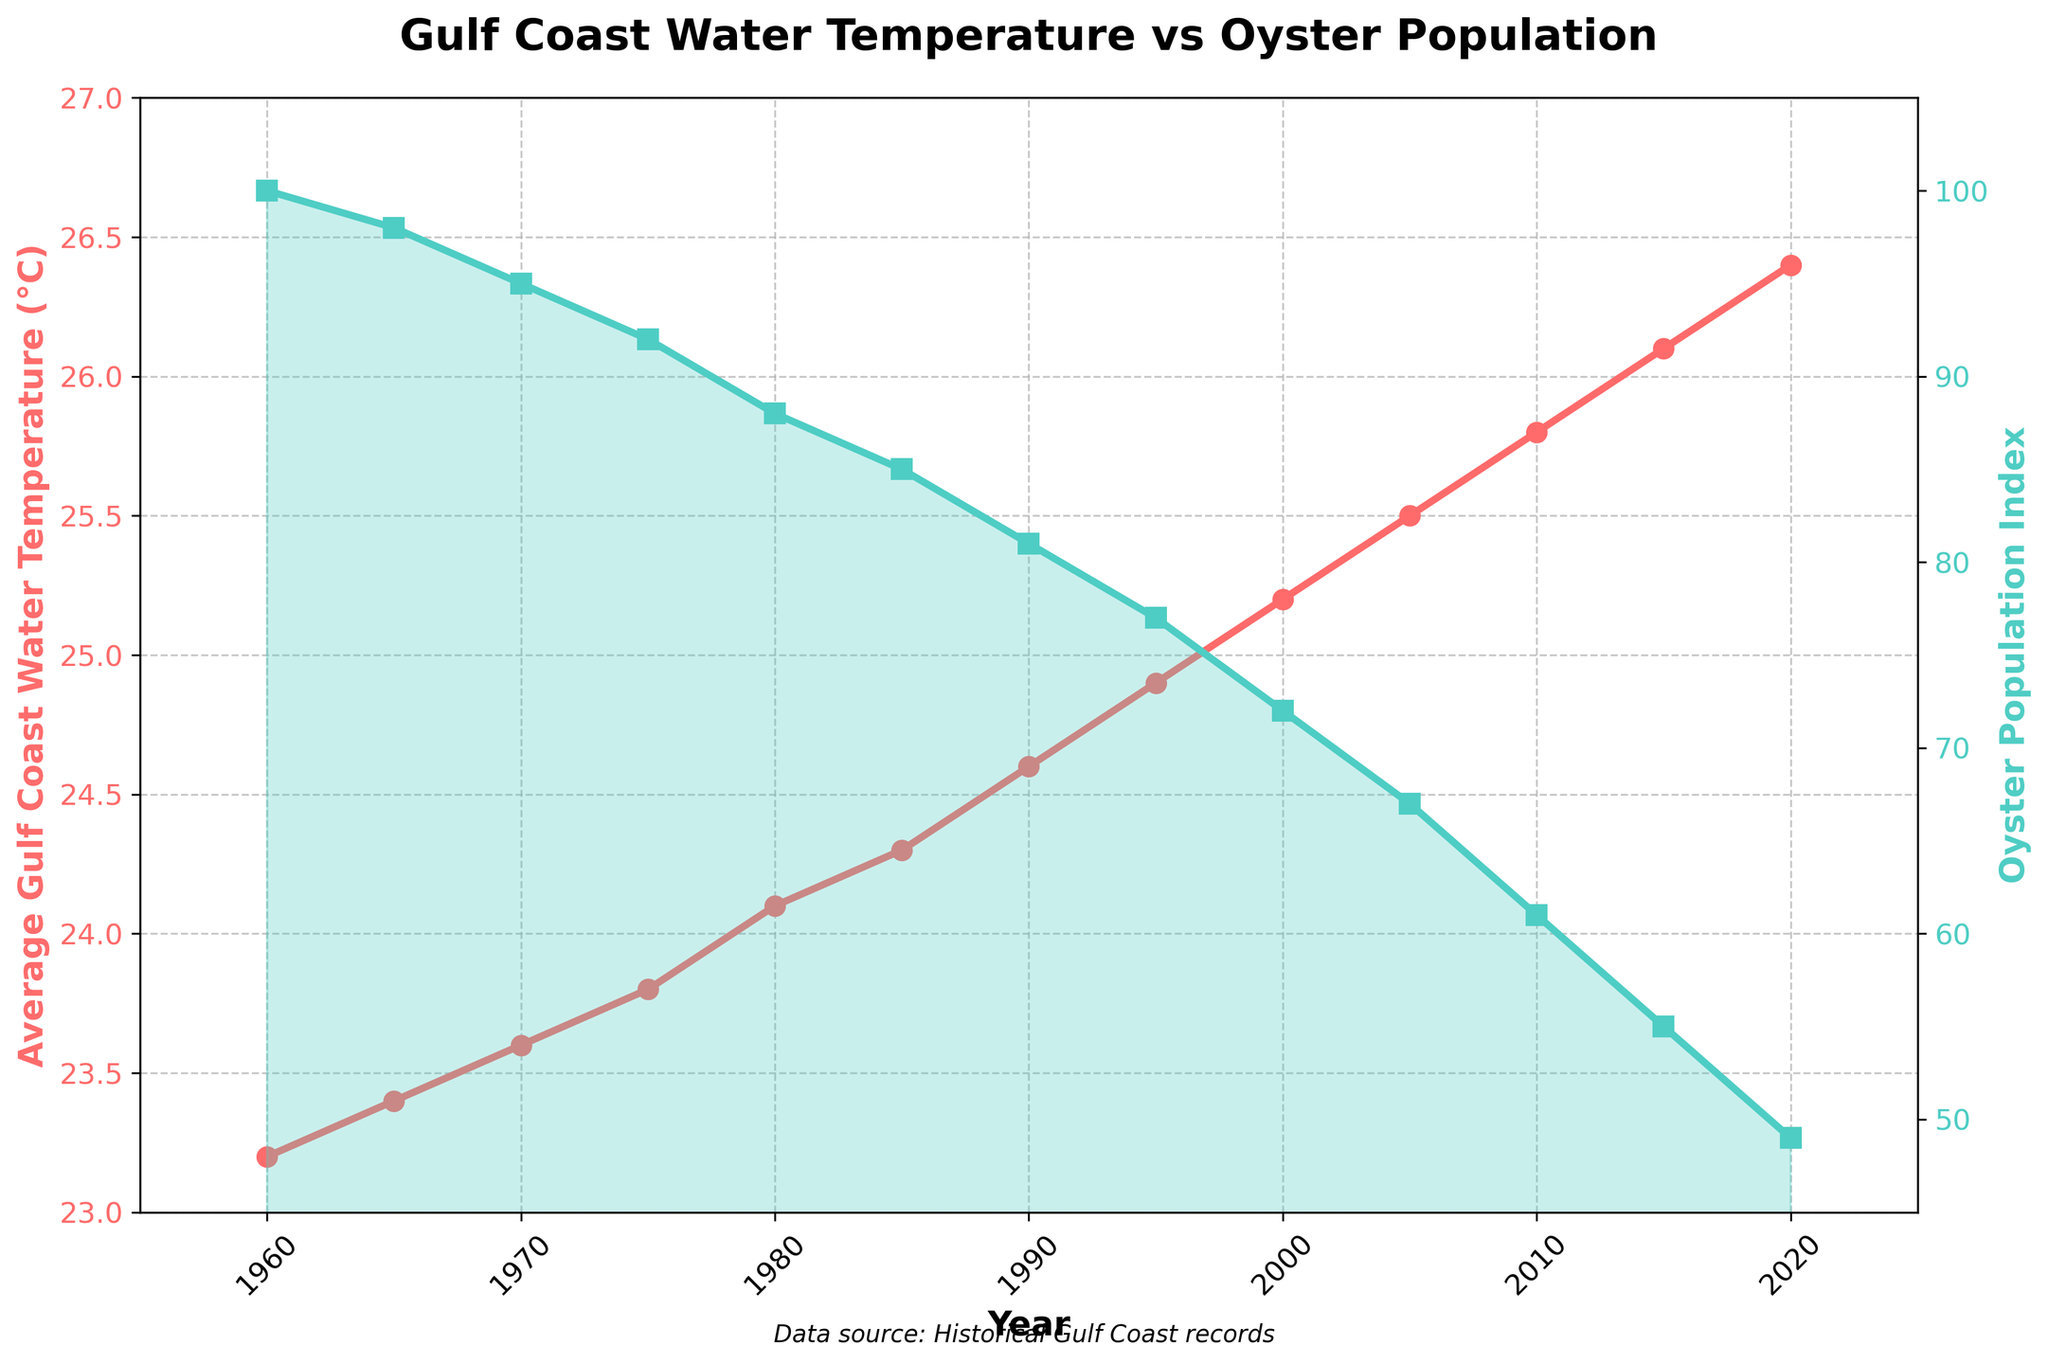How has the average Gulf Coast water temperature changed from 1960 to 2020? To find the change, subtract the average temperature in 1960 from the average temperature in 2020. The temperature in 1960 was 23.2°C and in 2020 it was 26.4°C. So, 26.4°C - 23.2°C = 3.2°C
Answer: 3.2°C What is the trend in the oyster population index from 1960 to 2020? Observing the line representing the oyster population index, it can be seen that the index has steadily decreased from 100 in 1960 to 49 in 2020
Answer: Decreasing During which period did the oyster population index experience the sharpest decline? By comparing the distances between the markers on the oyster population index line, the sharpest decline occurred between 2000 (index 72) and 2005 (index 67), i.e., 5 units
Answer: 2000 to 2005 Which year had the highest average Gulf Coast water temperature and what was the corresponding oyster population index? From the figure, 2020 shows the highest water temperature at 26.4°C. The corresponding oyster population index for 2020 is 49
Answer: 2020, 49 Is there a visible correlation between the increase in average water temperature and the decrease in the oyster population index? Observing the plot, there's a clear pattern indicating that as the average water temperature increases over the years, the oyster population index decreases
Answer: Yes How does the average water temperature in 1980 compare to that in 2000? The average water temperature in 1980 is 24.1°C. In 2000, it is 25.2°C. The temperature increased by 1.1°C (25.2°C - 24.1°C)
Answer: Increased by 1.1°C How many times does the oyster population index data point cross the value of 80? From the plot, the oyster population index crosses the value of 80 once, between 1985 and 1990
Answer: Once During which decade did the average Gulf Coast water temperature first rise above 24°C? By examining the plot, it can be seen that the average temperature crosses 24°C for the first time in the 1980s
Answer: 1980s What is the approximate average decline in the oyster population index per decade from 1960 to 2020? The total decline in the oyster population index from 1960 (index 100) to 2020 (index 49) is 51 units over 6 decades. Dividing the total decline by the number of decades, 51 / 6 ≈ 8.5 units per decade
Answer: Approximately 8.5 units per decade 